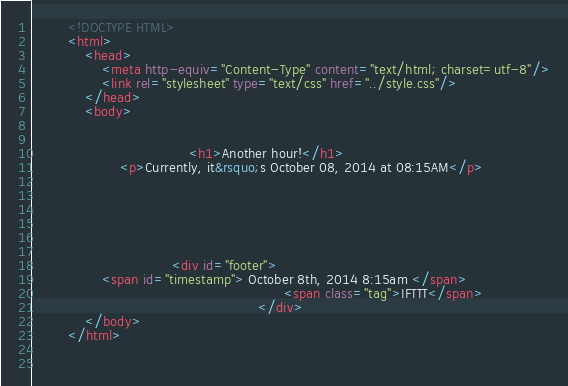Convert code to text. <code><loc_0><loc_0><loc_500><loc_500><_HTML_>        <!DOCTYPE HTML>
        <html>
            <head>
                <meta http-equiv="Content-Type" content="text/html; charset=utf-8"/>
                <link rel="stylesheet" type="text/css" href="../style.css"/>
            </head>
            <body>
                
                
                                    <h1>Another hour!</h1>
                    <p>Currently, it&rsquo;s October 08, 2014 at 08:15AM</p>
                
                
                
                
                
                
                                <div id="footer">
                <span id="timestamp"> October 8th, 2014 8:15am </span>
                                                          <span class="tag">IFTTT</span>
                                                    </div>
            </body>
        </html>

        </code> 